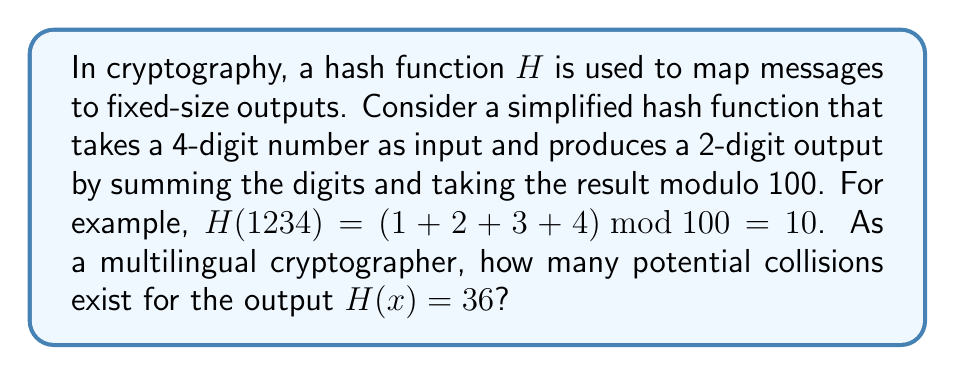Solve this math problem. Let's approach this step-by-step:

1) First, we need to understand what constitutes a collision. A collision occurs when two different inputs produce the same output.

2) In this case, we're looking for 4-digit numbers whose digits sum to 36 (since 36 mod 100 = 36).

3) The possible sums of 4 digits range from 0 (0000) to 36 (9999).

4) To find the number of ways to sum to 36 with 4 digits, we can use the stars and bars method from combinatorics. This is equivalent to finding the number of ways to put 36 identical objects into 4 distinct boxes.

5) The formula for this is:

   $$\binom{n+k-1}{k-1} = \binom{36+4-1}{4-1} = \binom{39}{3}$$

   Where $n = 36$ (the sum we're trying to achieve) and $k = 4$ (the number of digits).

6) Calculating this:

   $$\binom{39}{3} = \frac{39!}{3!(39-3)!} = \frac{39 \cdot 38 \cdot 37}{3 \cdot 2 \cdot 1} = 9139$$

7) However, this includes combinations that start with 0, which are not valid 4-digit numbers. We need to subtract these.

8) The number of combinations starting with 0 is equivalent to the number of ways to sum to 36 with 3 digits, which is:

   $$\binom{36+3-1}{3-1} = \binom{38}{2} = \frac{38 \cdot 37}{2 \cdot 1} = 703$$

9) Therefore, the total number of valid 4-digit numbers that hash to 36 is:

   $$9139 - 703 = 8436$$

This means there are 8436 potential collisions for the output $H(x) = 36$.
Answer: 8436 